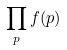<formula> <loc_0><loc_0><loc_500><loc_500>\prod _ { p } f ( p )</formula> 